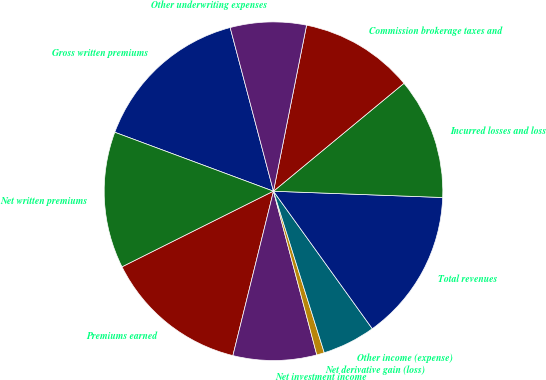Convert chart. <chart><loc_0><loc_0><loc_500><loc_500><pie_chart><fcel>Gross written premiums<fcel>Net written premiums<fcel>Premiums earned<fcel>Net investment income<fcel>Net derivative gain (loss)<fcel>Other income (expense)<fcel>Total revenues<fcel>Incurred losses and loss<fcel>Commission brokerage taxes and<fcel>Other underwriting expenses<nl><fcel>15.22%<fcel>13.04%<fcel>13.77%<fcel>7.97%<fcel>0.73%<fcel>5.07%<fcel>14.49%<fcel>11.59%<fcel>10.87%<fcel>7.25%<nl></chart> 